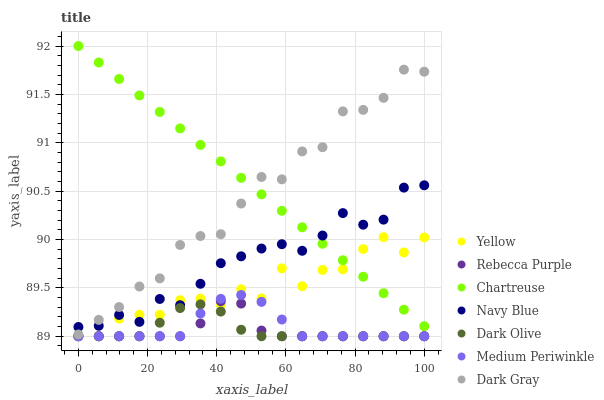Does Rebecca Purple have the minimum area under the curve?
Answer yes or no. Yes. Does Chartreuse have the maximum area under the curve?
Answer yes or no. Yes. Does Dark Olive have the minimum area under the curve?
Answer yes or no. No. Does Dark Olive have the maximum area under the curve?
Answer yes or no. No. Is Chartreuse the smoothest?
Answer yes or no. Yes. Is Yellow the roughest?
Answer yes or no. Yes. Is Dark Olive the smoothest?
Answer yes or no. No. Is Dark Olive the roughest?
Answer yes or no. No. Does Dark Olive have the lowest value?
Answer yes or no. Yes. Does Dark Gray have the lowest value?
Answer yes or no. No. Does Chartreuse have the highest value?
Answer yes or no. Yes. Does Medium Periwinkle have the highest value?
Answer yes or no. No. Is Medium Periwinkle less than Dark Gray?
Answer yes or no. Yes. Is Navy Blue greater than Rebecca Purple?
Answer yes or no. Yes. Does Navy Blue intersect Yellow?
Answer yes or no. Yes. Is Navy Blue less than Yellow?
Answer yes or no. No. Is Navy Blue greater than Yellow?
Answer yes or no. No. Does Medium Periwinkle intersect Dark Gray?
Answer yes or no. No. 